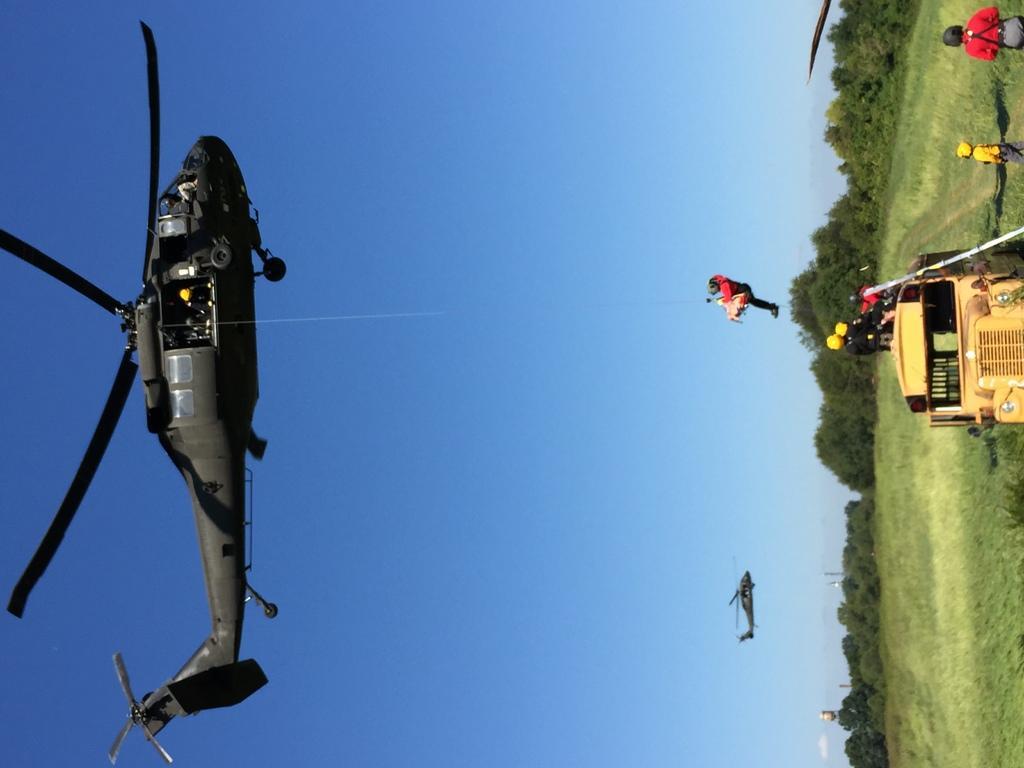Could you give a brief overview of what you see in this image? In this picture we can see couple of helicopters and group of people, on the right side of the image we can see a truck on the grass, in the background we can find few trees. 